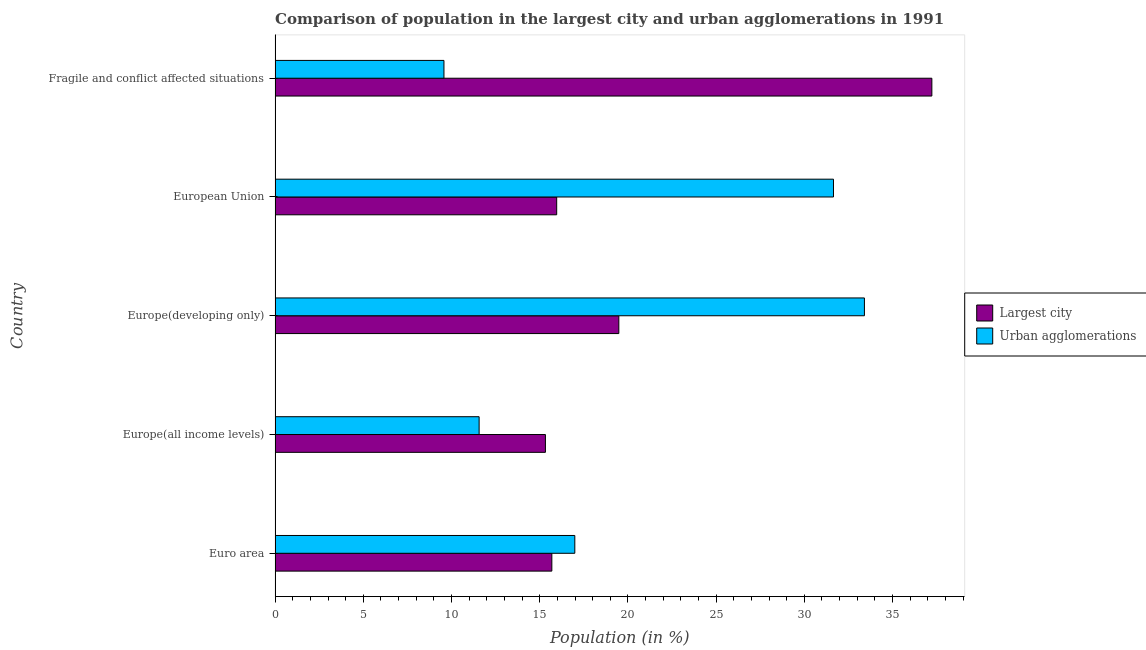Are the number of bars per tick equal to the number of legend labels?
Your answer should be compact. Yes. Are the number of bars on each tick of the Y-axis equal?
Your answer should be very brief. Yes. How many bars are there on the 4th tick from the bottom?
Provide a short and direct response. 2. What is the population in the largest city in Europe(developing only)?
Your answer should be very brief. 19.48. Across all countries, what is the maximum population in urban agglomerations?
Offer a very short reply. 33.41. Across all countries, what is the minimum population in the largest city?
Ensure brevity in your answer.  15.32. In which country was the population in urban agglomerations maximum?
Your answer should be compact. Europe(developing only). In which country was the population in urban agglomerations minimum?
Your response must be concise. Fragile and conflict affected situations. What is the total population in urban agglomerations in the graph?
Offer a terse response. 103.18. What is the difference between the population in urban agglomerations in Euro area and that in Europe(all income levels)?
Your answer should be compact. 5.42. What is the difference between the population in the largest city in Europe(developing only) and the population in urban agglomerations in European Union?
Provide a succinct answer. -12.17. What is the average population in urban agglomerations per country?
Make the answer very short. 20.64. What is the difference between the population in the largest city and population in urban agglomerations in Europe(all income levels)?
Ensure brevity in your answer.  3.76. What is the difference between the highest and the second highest population in urban agglomerations?
Provide a succinct answer. 1.75. What is the difference between the highest and the lowest population in the largest city?
Your answer should be compact. 21.9. In how many countries, is the population in urban agglomerations greater than the average population in urban agglomerations taken over all countries?
Your answer should be compact. 2. What does the 2nd bar from the top in Fragile and conflict affected situations represents?
Offer a very short reply. Largest city. What does the 1st bar from the bottom in Fragile and conflict affected situations represents?
Offer a very short reply. Largest city. What is the difference between two consecutive major ticks on the X-axis?
Provide a succinct answer. 5. Are the values on the major ticks of X-axis written in scientific E-notation?
Your response must be concise. No. Does the graph contain any zero values?
Your answer should be very brief. No. Where does the legend appear in the graph?
Keep it short and to the point. Center right. How are the legend labels stacked?
Your answer should be compact. Vertical. What is the title of the graph?
Provide a short and direct response. Comparison of population in the largest city and urban agglomerations in 1991. What is the Population (in %) in Largest city in Euro area?
Offer a very short reply. 15.69. What is the Population (in %) in Urban agglomerations in Euro area?
Provide a succinct answer. 16.99. What is the Population (in %) of Largest city in Europe(all income levels)?
Ensure brevity in your answer.  15.32. What is the Population (in %) of Urban agglomerations in Europe(all income levels)?
Your response must be concise. 11.57. What is the Population (in %) in Largest city in Europe(developing only)?
Offer a very short reply. 19.48. What is the Population (in %) of Urban agglomerations in Europe(developing only)?
Ensure brevity in your answer.  33.41. What is the Population (in %) of Largest city in European Union?
Offer a terse response. 15.96. What is the Population (in %) of Urban agglomerations in European Union?
Your answer should be very brief. 31.65. What is the Population (in %) of Largest city in Fragile and conflict affected situations?
Provide a short and direct response. 37.23. What is the Population (in %) of Urban agglomerations in Fragile and conflict affected situations?
Provide a succinct answer. 9.57. Across all countries, what is the maximum Population (in %) in Largest city?
Ensure brevity in your answer.  37.23. Across all countries, what is the maximum Population (in %) in Urban agglomerations?
Your response must be concise. 33.41. Across all countries, what is the minimum Population (in %) in Largest city?
Provide a succinct answer. 15.32. Across all countries, what is the minimum Population (in %) of Urban agglomerations?
Provide a succinct answer. 9.57. What is the total Population (in %) of Largest city in the graph?
Your response must be concise. 103.69. What is the total Population (in %) in Urban agglomerations in the graph?
Offer a very short reply. 103.18. What is the difference between the Population (in %) in Largest city in Euro area and that in Europe(all income levels)?
Offer a terse response. 0.36. What is the difference between the Population (in %) in Urban agglomerations in Euro area and that in Europe(all income levels)?
Offer a very short reply. 5.42. What is the difference between the Population (in %) of Largest city in Euro area and that in Europe(developing only)?
Your answer should be compact. -3.8. What is the difference between the Population (in %) in Urban agglomerations in Euro area and that in Europe(developing only)?
Offer a terse response. -16.42. What is the difference between the Population (in %) in Largest city in Euro area and that in European Union?
Provide a succinct answer. -0.27. What is the difference between the Population (in %) of Urban agglomerations in Euro area and that in European Union?
Your answer should be very brief. -14.66. What is the difference between the Population (in %) of Largest city in Euro area and that in Fragile and conflict affected situations?
Your answer should be very brief. -21.54. What is the difference between the Population (in %) of Urban agglomerations in Euro area and that in Fragile and conflict affected situations?
Your response must be concise. 7.42. What is the difference between the Population (in %) in Largest city in Europe(all income levels) and that in Europe(developing only)?
Ensure brevity in your answer.  -4.16. What is the difference between the Population (in %) in Urban agglomerations in Europe(all income levels) and that in Europe(developing only)?
Offer a terse response. -21.84. What is the difference between the Population (in %) of Largest city in Europe(all income levels) and that in European Union?
Provide a short and direct response. -0.64. What is the difference between the Population (in %) in Urban agglomerations in Europe(all income levels) and that in European Union?
Your answer should be compact. -20.09. What is the difference between the Population (in %) of Largest city in Europe(all income levels) and that in Fragile and conflict affected situations?
Your answer should be very brief. -21.9. What is the difference between the Population (in %) in Urban agglomerations in Europe(all income levels) and that in Fragile and conflict affected situations?
Offer a very short reply. 1.99. What is the difference between the Population (in %) of Largest city in Europe(developing only) and that in European Union?
Offer a terse response. 3.52. What is the difference between the Population (in %) of Urban agglomerations in Europe(developing only) and that in European Union?
Offer a terse response. 1.75. What is the difference between the Population (in %) of Largest city in Europe(developing only) and that in Fragile and conflict affected situations?
Keep it short and to the point. -17.74. What is the difference between the Population (in %) of Urban agglomerations in Europe(developing only) and that in Fragile and conflict affected situations?
Offer a very short reply. 23.83. What is the difference between the Population (in %) in Largest city in European Union and that in Fragile and conflict affected situations?
Your response must be concise. -21.27. What is the difference between the Population (in %) of Urban agglomerations in European Union and that in Fragile and conflict affected situations?
Your answer should be compact. 22.08. What is the difference between the Population (in %) of Largest city in Euro area and the Population (in %) of Urban agglomerations in Europe(all income levels)?
Offer a very short reply. 4.12. What is the difference between the Population (in %) in Largest city in Euro area and the Population (in %) in Urban agglomerations in Europe(developing only)?
Offer a very short reply. -17.72. What is the difference between the Population (in %) in Largest city in Euro area and the Population (in %) in Urban agglomerations in European Union?
Ensure brevity in your answer.  -15.96. What is the difference between the Population (in %) of Largest city in Euro area and the Population (in %) of Urban agglomerations in Fragile and conflict affected situations?
Keep it short and to the point. 6.12. What is the difference between the Population (in %) in Largest city in Europe(all income levels) and the Population (in %) in Urban agglomerations in Europe(developing only)?
Give a very brief answer. -18.08. What is the difference between the Population (in %) of Largest city in Europe(all income levels) and the Population (in %) of Urban agglomerations in European Union?
Your answer should be very brief. -16.33. What is the difference between the Population (in %) of Largest city in Europe(all income levels) and the Population (in %) of Urban agglomerations in Fragile and conflict affected situations?
Your answer should be compact. 5.75. What is the difference between the Population (in %) in Largest city in Europe(developing only) and the Population (in %) in Urban agglomerations in European Union?
Provide a succinct answer. -12.17. What is the difference between the Population (in %) of Largest city in Europe(developing only) and the Population (in %) of Urban agglomerations in Fragile and conflict affected situations?
Offer a very short reply. 9.91. What is the difference between the Population (in %) of Largest city in European Union and the Population (in %) of Urban agglomerations in Fragile and conflict affected situations?
Keep it short and to the point. 6.39. What is the average Population (in %) in Largest city per country?
Offer a very short reply. 20.74. What is the average Population (in %) of Urban agglomerations per country?
Make the answer very short. 20.64. What is the difference between the Population (in %) in Largest city and Population (in %) in Urban agglomerations in Euro area?
Your response must be concise. -1.3. What is the difference between the Population (in %) of Largest city and Population (in %) of Urban agglomerations in Europe(all income levels)?
Provide a succinct answer. 3.76. What is the difference between the Population (in %) in Largest city and Population (in %) in Urban agglomerations in Europe(developing only)?
Keep it short and to the point. -13.92. What is the difference between the Population (in %) in Largest city and Population (in %) in Urban agglomerations in European Union?
Offer a very short reply. -15.69. What is the difference between the Population (in %) in Largest city and Population (in %) in Urban agglomerations in Fragile and conflict affected situations?
Make the answer very short. 27.66. What is the ratio of the Population (in %) of Largest city in Euro area to that in Europe(all income levels)?
Give a very brief answer. 1.02. What is the ratio of the Population (in %) of Urban agglomerations in Euro area to that in Europe(all income levels)?
Offer a very short reply. 1.47. What is the ratio of the Population (in %) in Largest city in Euro area to that in Europe(developing only)?
Give a very brief answer. 0.81. What is the ratio of the Population (in %) in Urban agglomerations in Euro area to that in Europe(developing only)?
Your response must be concise. 0.51. What is the ratio of the Population (in %) in Largest city in Euro area to that in European Union?
Provide a succinct answer. 0.98. What is the ratio of the Population (in %) in Urban agglomerations in Euro area to that in European Union?
Give a very brief answer. 0.54. What is the ratio of the Population (in %) in Largest city in Euro area to that in Fragile and conflict affected situations?
Ensure brevity in your answer.  0.42. What is the ratio of the Population (in %) in Urban agglomerations in Euro area to that in Fragile and conflict affected situations?
Your response must be concise. 1.77. What is the ratio of the Population (in %) of Largest city in Europe(all income levels) to that in Europe(developing only)?
Your answer should be very brief. 0.79. What is the ratio of the Population (in %) of Urban agglomerations in Europe(all income levels) to that in Europe(developing only)?
Offer a terse response. 0.35. What is the ratio of the Population (in %) of Urban agglomerations in Europe(all income levels) to that in European Union?
Offer a terse response. 0.37. What is the ratio of the Population (in %) of Largest city in Europe(all income levels) to that in Fragile and conflict affected situations?
Offer a very short reply. 0.41. What is the ratio of the Population (in %) of Urban agglomerations in Europe(all income levels) to that in Fragile and conflict affected situations?
Make the answer very short. 1.21. What is the ratio of the Population (in %) of Largest city in Europe(developing only) to that in European Union?
Provide a short and direct response. 1.22. What is the ratio of the Population (in %) of Urban agglomerations in Europe(developing only) to that in European Union?
Provide a succinct answer. 1.06. What is the ratio of the Population (in %) in Largest city in Europe(developing only) to that in Fragile and conflict affected situations?
Provide a succinct answer. 0.52. What is the ratio of the Population (in %) of Urban agglomerations in Europe(developing only) to that in Fragile and conflict affected situations?
Keep it short and to the point. 3.49. What is the ratio of the Population (in %) in Largest city in European Union to that in Fragile and conflict affected situations?
Ensure brevity in your answer.  0.43. What is the ratio of the Population (in %) of Urban agglomerations in European Union to that in Fragile and conflict affected situations?
Ensure brevity in your answer.  3.31. What is the difference between the highest and the second highest Population (in %) of Largest city?
Your response must be concise. 17.74. What is the difference between the highest and the second highest Population (in %) of Urban agglomerations?
Your response must be concise. 1.75. What is the difference between the highest and the lowest Population (in %) of Largest city?
Keep it short and to the point. 21.9. What is the difference between the highest and the lowest Population (in %) of Urban agglomerations?
Provide a short and direct response. 23.83. 